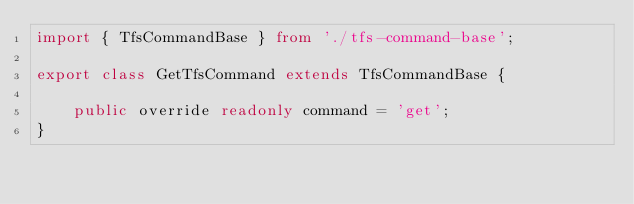Convert code to text. <code><loc_0><loc_0><loc_500><loc_500><_TypeScript_>import { TfsCommandBase } from './tfs-command-base';

export class GetTfsCommand extends TfsCommandBase {

    public override readonly command = 'get';
}</code> 